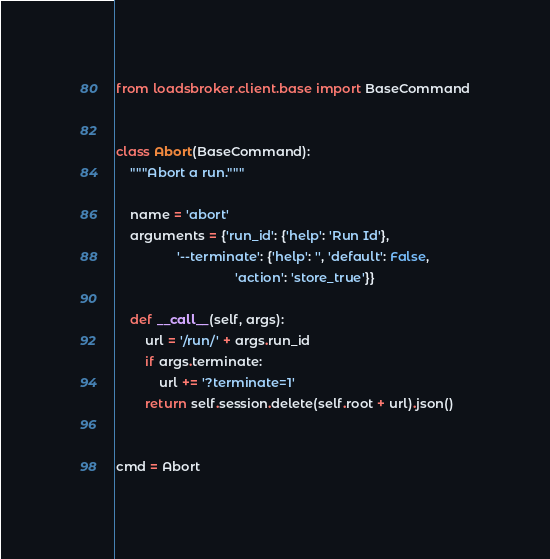Convert code to text. <code><loc_0><loc_0><loc_500><loc_500><_Python_>from loadsbroker.client.base import BaseCommand


class Abort(BaseCommand):
    """Abort a run."""

    name = 'abort'
    arguments = {'run_id': {'help': 'Run Id'},
                 '--terminate': {'help': '', 'default': False,
                                 'action': 'store_true'}}

    def __call__(self, args):
        url = '/run/' + args.run_id
        if args.terminate:
            url += '?terminate=1'
        return self.session.delete(self.root + url).json()


cmd = Abort
</code> 